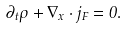<formula> <loc_0><loc_0><loc_500><loc_500>\partial _ { t } \rho + \nabla _ { x } \cdot j _ { F } = 0 .</formula> 